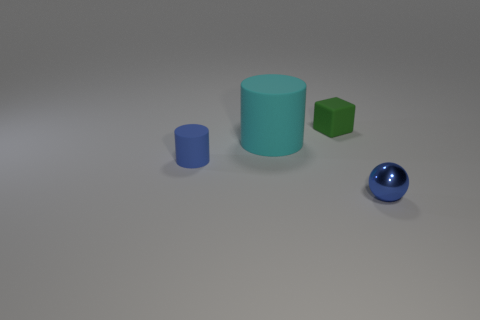How many balls are small metal objects or cyan things?
Keep it short and to the point. 1. Are there any small purple matte blocks?
Your answer should be very brief. No. How many other objects are the same material as the small blue ball?
Keep it short and to the point. 0. What is the material of the green object that is the same size as the blue metal object?
Offer a very short reply. Rubber. There is a tiny thing that is on the left side of the small rubber block; is it the same shape as the green object?
Your answer should be very brief. No. Is the metal object the same color as the small rubber cylinder?
Ensure brevity in your answer.  Yes. How many things are objects to the left of the small ball or big cyan spheres?
Give a very brief answer. 3. What shape is the other rubber object that is the same size as the green rubber thing?
Your response must be concise. Cylinder. Does the cylinder in front of the cyan matte cylinder have the same size as the cylinder that is to the right of the small blue rubber cylinder?
Provide a short and direct response. No. There is a tiny block that is made of the same material as the large cyan cylinder; what color is it?
Provide a short and direct response. Green. 